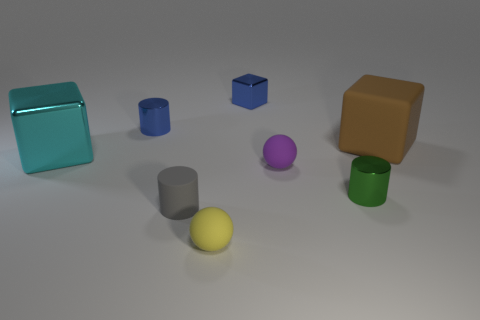Can you tell me what materials the objects seem to be made of? The objects exhibit different finishes and lusters suggesting a mix of materials. For example, the cube in the front left has a reflective surface implying it could be made of a polished metal or plastic; the purple and yellow spheres have a diffuse, matte appearance which could suggest a clay or rubber material. 